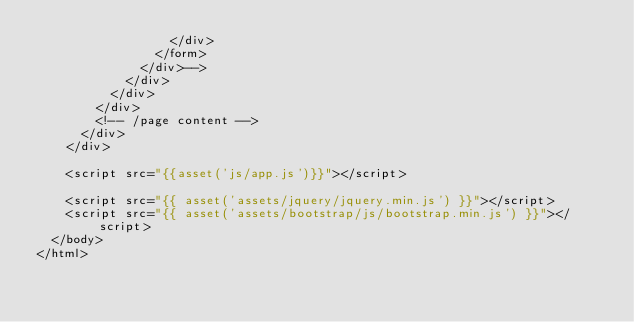Convert code to text. <code><loc_0><loc_0><loc_500><loc_500><_PHP_>                  </div>
                </form>
              </div>-->
            </div>
          </div>
        </div>
        <!-- /page content -->
      </div>
    </div>

    <script src="{{asset('js/app.js')}}"></script>

    <script src="{{ asset('assets/jquery/jquery.min.js') }}"></script>
    <script src="{{ asset('assets/bootstrap/js/bootstrap.min.js') }}"></script>
  </body>
</html></code> 